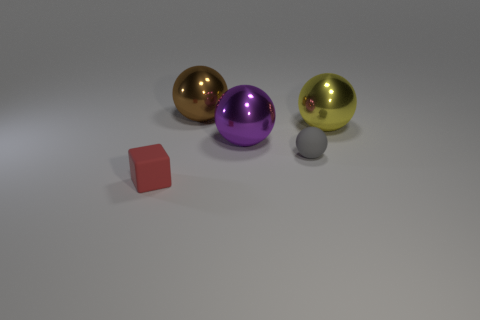Add 4 tiny red things. How many objects exist? 9 Subtract all cubes. How many objects are left? 4 Subtract 0 cyan spheres. How many objects are left? 5 Subtract all red shiny cubes. Subtract all brown objects. How many objects are left? 4 Add 5 rubber things. How many rubber things are left? 7 Add 4 yellow matte objects. How many yellow matte objects exist? 4 